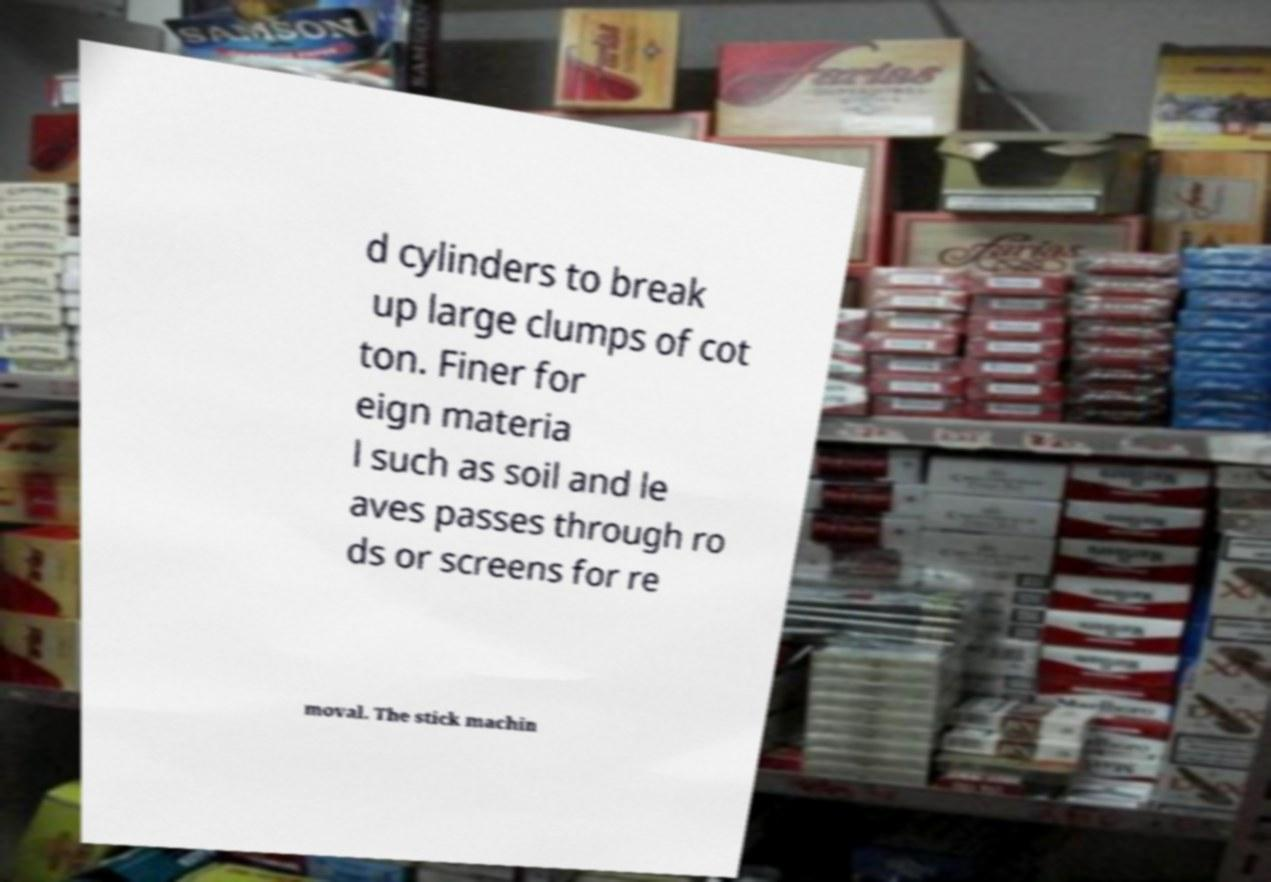Could you assist in decoding the text presented in this image and type it out clearly? d cylinders to break up large clumps of cot ton. Finer for eign materia l such as soil and le aves passes through ro ds or screens for re moval. The stick machin 